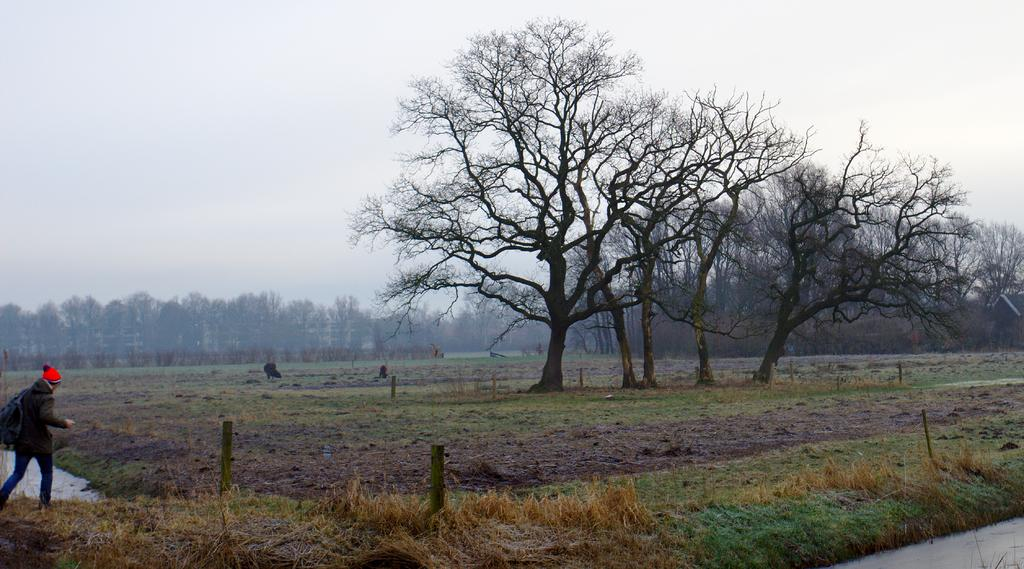What type of vegetation can be seen in the image? There are trees in the image. What is the woman in the image doing? The woman is walking in the image. What is the woman carrying on her back? The woman is wearing a backpack. What type of ground surface is visible in the image? There is grass on the ground in the image. What is the condition of the sky in the image? The sky is cloudy in the image. What type of water is visible in the image? There is water visible in the image. What type of development is taking place near the water in the image? There is no development or construction activity visible in the image. What sound does the alarm make in the image? There is no alarm present in the image. What color is the gold jewelry worn by the woman in the image? The woman in the image is not wearing any gold jewelry. 